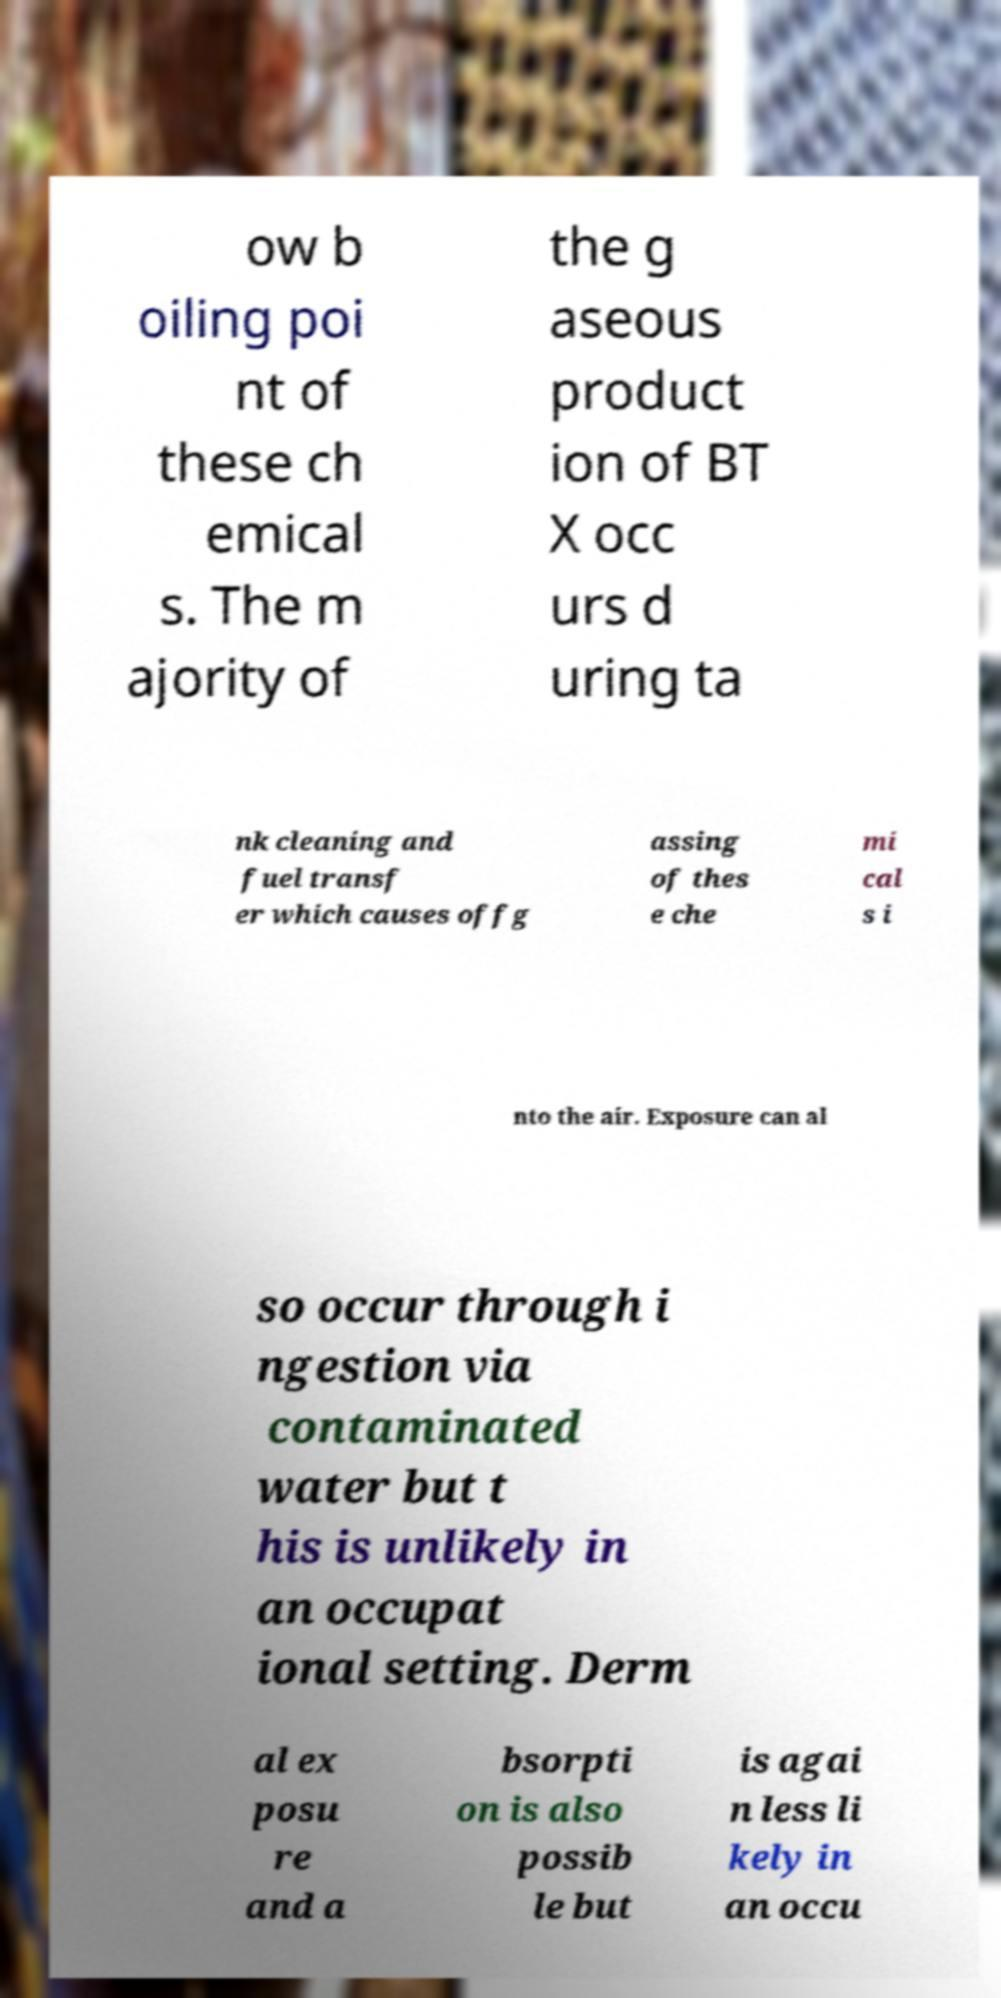Please identify and transcribe the text found in this image. ow b oiling poi nt of these ch emical s. The m ajority of the g aseous product ion of BT X occ urs d uring ta nk cleaning and fuel transf er which causes offg assing of thes e che mi cal s i nto the air. Exposure can al so occur through i ngestion via contaminated water but t his is unlikely in an occupat ional setting. Derm al ex posu re and a bsorpti on is also possib le but is agai n less li kely in an occu 